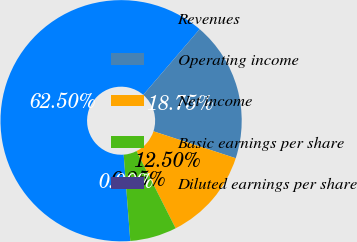Convert chart to OTSL. <chart><loc_0><loc_0><loc_500><loc_500><pie_chart><fcel>Revenues<fcel>Operating income<fcel>Net income<fcel>Basic earnings per share<fcel>Diluted earnings per share<nl><fcel>62.5%<fcel>18.75%<fcel>12.5%<fcel>6.25%<fcel>0.0%<nl></chart> 